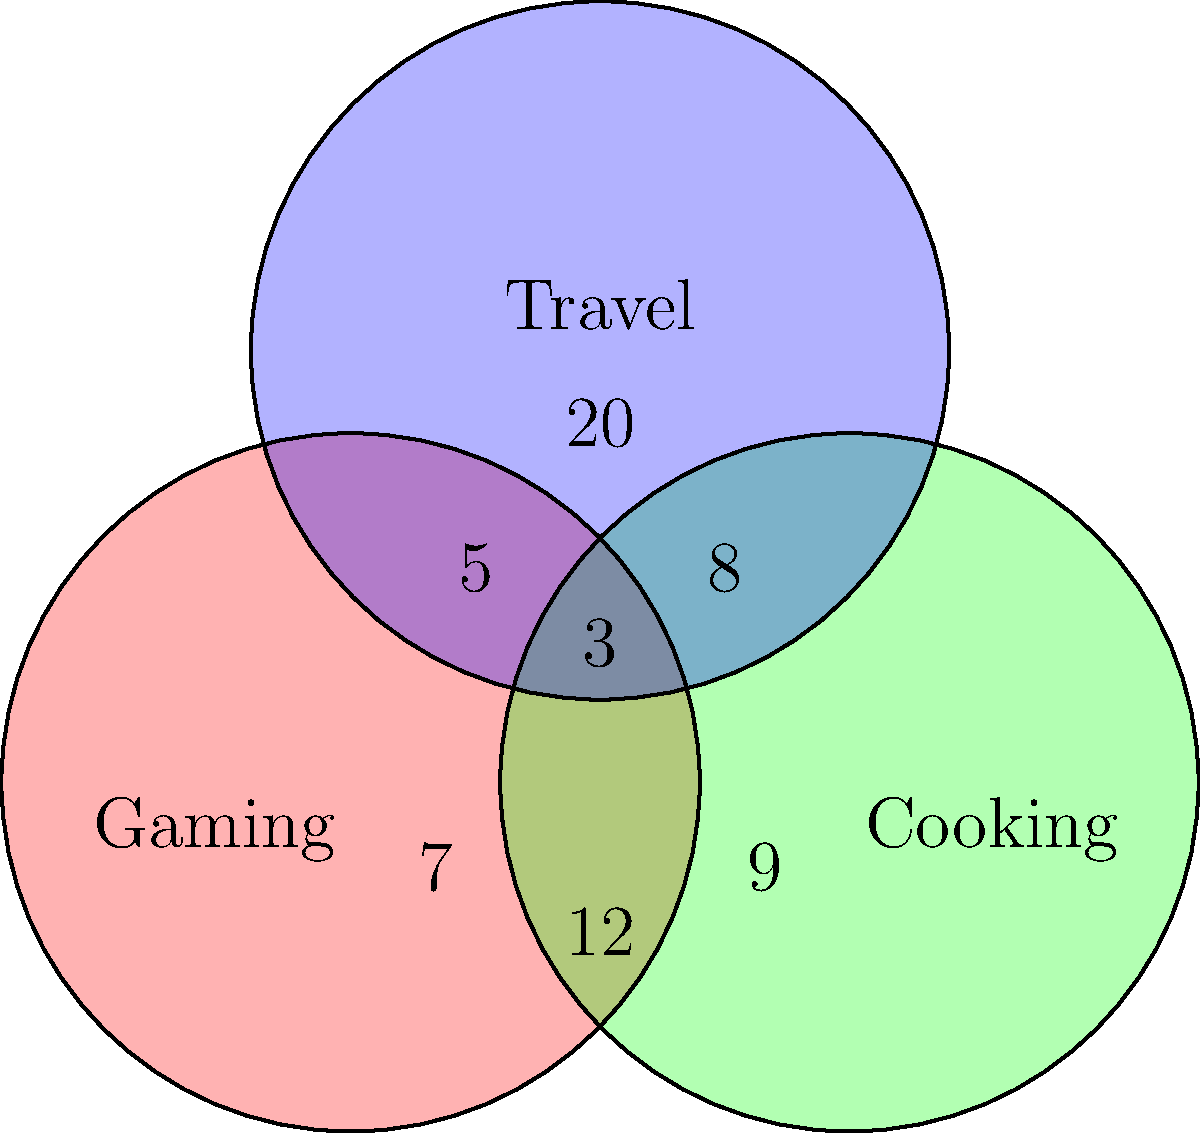You're investigating three online profiles suspected to belong to the same individual. The Venn diagram shows overlapping interests across these profiles. Each number represents unique posts related to that interest or combination of interests. If you're looking for the profile with the most diverse range of interests, how many total posts should it have? To find the profile with the most diverse range of interests, we need to identify the region in the Venn diagram that overlaps with all three circles. This represents a profile that has posts related to all three interests: Gaming, Cooking, and Travel.

Step 1: Identify the center region where all three circles overlap.
This region contains 3 posts.

Step 2: Add the posts from regions that overlap with two interests:
- Gaming and Cooking: 12 posts
- Gaming and Travel: 5 posts
- Cooking and Travel: 8 posts

Step 3: Add the posts from the center region to these overlapping regions:
3 + 12 + 5 + 8 = 28 posts

This sum represents the total number of posts that demonstrate interest in at least two categories or all three categories, which indicates the most diverse range of interests.

Therefore, the profile with the most diverse range of interests should have 28 total posts.
Answer: 28 posts 